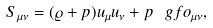Convert formula to latex. <formula><loc_0><loc_0><loc_500><loc_500>S _ { \mu \nu } = ( \varrho + p ) u _ { \mu } u _ { \nu } + p \ g f o _ { \mu \nu } ,</formula> 